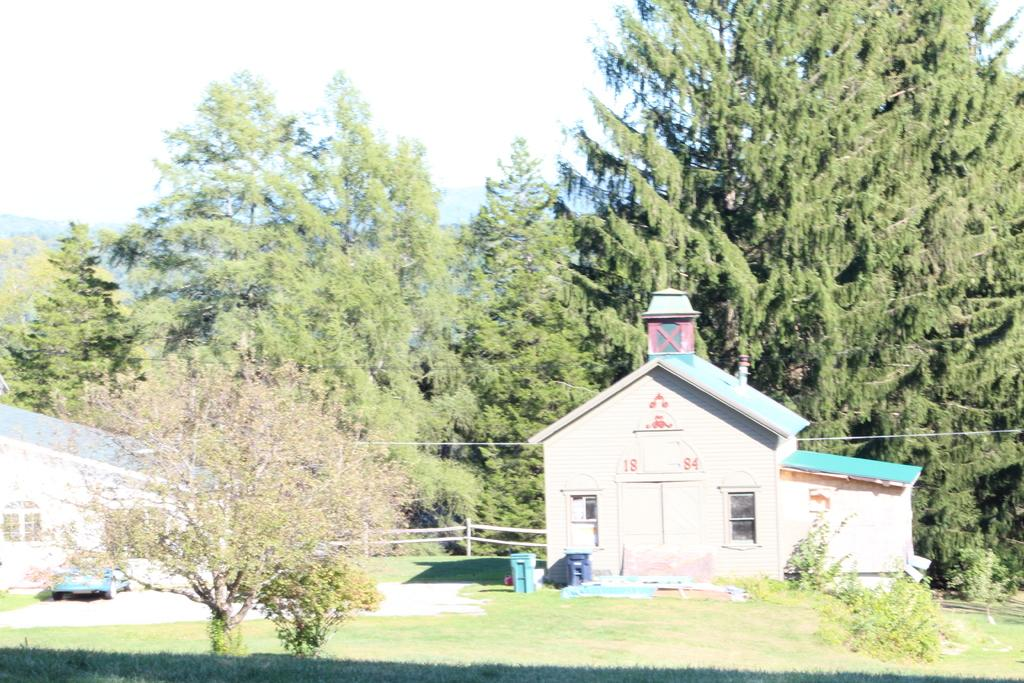What type of houses can be seen in the image? There are wooden houses in the image. What is parked near the wooden houses? A car is parked in the image. What type of terrain is visible in the image? There is grassland visible in the image. What other natural elements are present in the image? Trees are present in the image. What man-made objects can be seen in the image? Trash cans and wires are visible in the image. What type of barrier is present in the image? There is a fence in the image. What can be seen in the background of the image? The sky is visible in the background of the image. What type of interest can be seen growing on the trees in the image? There is no mention of any interest growing on the trees in the image. Is there any evidence of war in the image? There is no indication of war or any conflict in the image. 